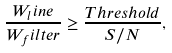Convert formula to latex. <formula><loc_0><loc_0><loc_500><loc_500>\frac { W _ { l } i n e } { W _ { f } i l t e r } \geq \frac { T h r e s h o l d } { S / N } ,</formula> 